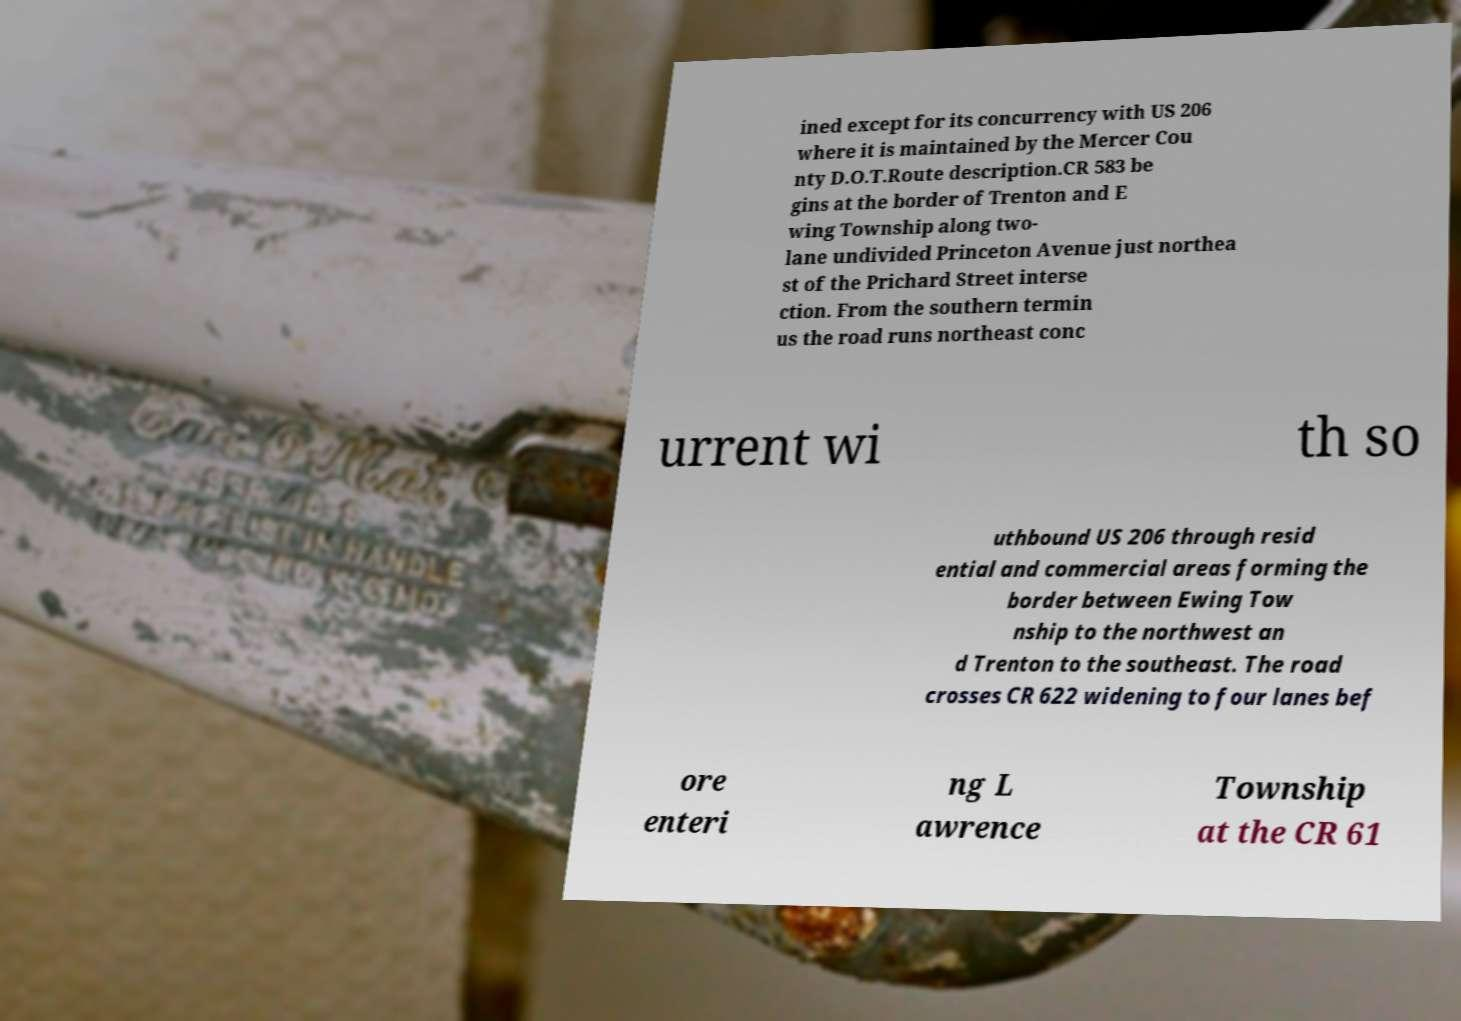Could you assist in decoding the text presented in this image and type it out clearly? ined except for its concurrency with US 206 where it is maintained by the Mercer Cou nty D.O.T.Route description.CR 583 be gins at the border of Trenton and E wing Township along two- lane undivided Princeton Avenue just northea st of the Prichard Street interse ction. From the southern termin us the road runs northeast conc urrent wi th so uthbound US 206 through resid ential and commercial areas forming the border between Ewing Tow nship to the northwest an d Trenton to the southeast. The road crosses CR 622 widening to four lanes bef ore enteri ng L awrence Township at the CR 61 